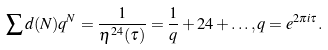<formula> <loc_0><loc_0><loc_500><loc_500>\sum d ( N ) q ^ { N } = \frac { 1 } { \eta ^ { 2 4 } ( \tau ) } = \frac { 1 } { q } + 2 4 + \dots , q = e ^ { 2 \pi i \tau } .</formula> 